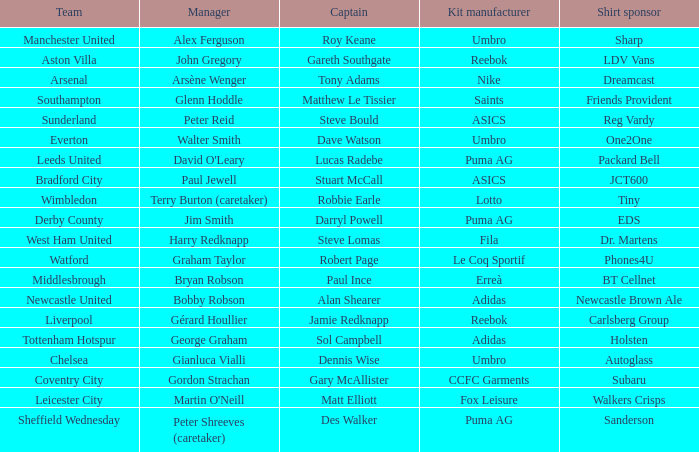Could you help me parse every detail presented in this table? {'header': ['Team', 'Manager', 'Captain', 'Kit manufacturer', 'Shirt sponsor'], 'rows': [['Manchester United', 'Alex Ferguson', 'Roy Keane', 'Umbro', 'Sharp'], ['Aston Villa', 'John Gregory', 'Gareth Southgate', 'Reebok', 'LDV Vans'], ['Arsenal', 'Arsène Wenger', 'Tony Adams', 'Nike', 'Dreamcast'], ['Southampton', 'Glenn Hoddle', 'Matthew Le Tissier', 'Saints', 'Friends Provident'], ['Sunderland', 'Peter Reid', 'Steve Bould', 'ASICS', 'Reg Vardy'], ['Everton', 'Walter Smith', 'Dave Watson', 'Umbro', 'One2One'], ['Leeds United', "David O'Leary", 'Lucas Radebe', 'Puma AG', 'Packard Bell'], ['Bradford City', 'Paul Jewell', 'Stuart McCall', 'ASICS', 'JCT600'], ['Wimbledon', 'Terry Burton (caretaker)', 'Robbie Earle', 'Lotto', 'Tiny'], ['Derby County', 'Jim Smith', 'Darryl Powell', 'Puma AG', 'EDS'], ['West Ham United', 'Harry Redknapp', 'Steve Lomas', 'Fila', 'Dr. Martens'], ['Watford', 'Graham Taylor', 'Robert Page', 'Le Coq Sportif', 'Phones4U'], ['Middlesbrough', 'Bryan Robson', 'Paul Ince', 'Erreà', 'BT Cellnet'], ['Newcastle United', 'Bobby Robson', 'Alan Shearer', 'Adidas', 'Newcastle Brown Ale'], ['Liverpool', 'Gérard Houllier', 'Jamie Redknapp', 'Reebok', 'Carlsberg Group'], ['Tottenham Hotspur', 'George Graham', 'Sol Campbell', 'Adidas', 'Holsten'], ['Chelsea', 'Gianluca Vialli', 'Dennis Wise', 'Umbro', 'Autoglass'], ['Coventry City', 'Gordon Strachan', 'Gary McAllister', 'CCFC Garments', 'Subaru'], ['Leicester City', "Martin O'Neill", 'Matt Elliott', 'Fox Leisure', 'Walkers Crisps'], ['Sheffield Wednesday', 'Peter Shreeves (caretaker)', 'Des Walker', 'Puma AG', 'Sanderson']]} Which captain is managed by gianluca vialli? Dennis Wise. 